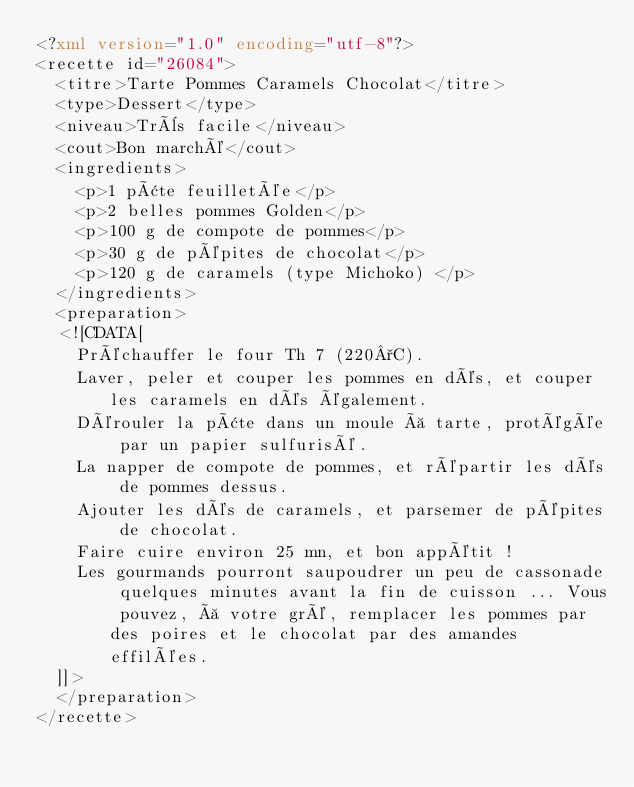Convert code to text. <code><loc_0><loc_0><loc_500><loc_500><_XML_><?xml version="1.0" encoding="utf-8"?>
<recette id="26084">
  <titre>Tarte Pommes Caramels Chocolat</titre>
  <type>Dessert</type>
  <niveau>Très facile</niveau>
  <cout>Bon marché</cout>
  <ingredients>
    <p>1 pâte feuilletée</p>
    <p>2 belles pommes Golden</p>
    <p>100 g de compote de pommes</p>
    <p>30 g de pépites de chocolat</p>
    <p>120 g de caramels (type Michoko) </p>
  </ingredients>
  <preparation>
  <![CDATA[
    Préchauffer le four Th 7 (220°C). 
    Laver, peler et couper les pommes en dés, et couper les caramels en dés également. 
    Dérouler la pâte dans un moule à tarte, protégée par un papier sulfurisé. 
    La napper de compote de pommes, et répartir les dés de pommes dessus. 
    Ajouter les dés de caramels, et parsemer de pépites de chocolat. 
    Faire cuire environ 25 mn, et bon appétit !
    Les gourmands pourront saupoudrer un peu de cassonade quelques minutes avant la fin de cuisson ... Vous pouvez, à votre gré, remplacer les pommes par des poires et le chocolat par des amandes effilées.
  ]]>
  </preparation>
</recette>
</code> 